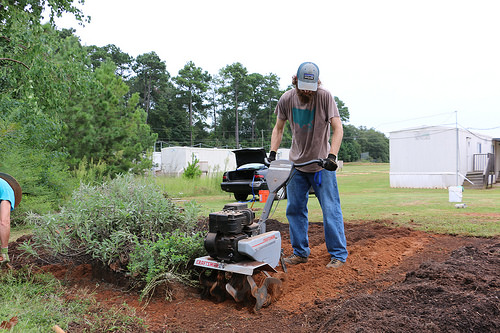<image>
Is the hat behind the man? No. The hat is not behind the man. From this viewpoint, the hat appears to be positioned elsewhere in the scene. Where is the machine in relation to the person? Is it in front of the person? Yes. The machine is positioned in front of the person, appearing closer to the camera viewpoint. 